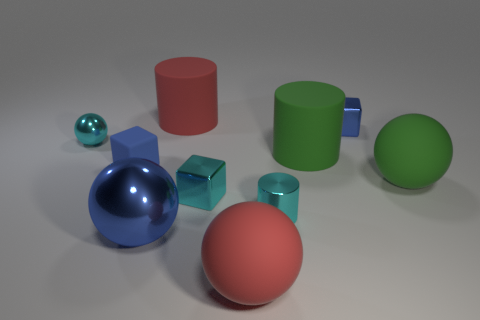There is a blue object that is both behind the green sphere and in front of the small blue metallic block; what is its size?
Offer a terse response. Small. How many other things are the same color as the small sphere?
Keep it short and to the point. 2. Is the small cube that is in front of the big green rubber ball made of the same material as the big green ball?
Make the answer very short. No. Are there fewer cyan objects that are right of the big green matte ball than small metal objects that are left of the red matte cylinder?
Your answer should be compact. Yes. There is a blue thing that is to the right of the big red thing behind the big blue metal thing; what number of large rubber spheres are in front of it?
Provide a succinct answer. 2. There is a blue rubber block; what number of tiny cyan shiny balls are in front of it?
Ensure brevity in your answer.  0. What number of big red objects are made of the same material as the small cylinder?
Your answer should be very brief. 0. What is the color of the tiny cylinder that is made of the same material as the blue sphere?
Provide a succinct answer. Cyan. The small blue cube left of the big red rubber object to the right of the large cylinder that is to the left of the red ball is made of what material?
Offer a terse response. Rubber. Do the cube in front of the green ball and the cyan metal ball have the same size?
Provide a short and direct response. Yes. 